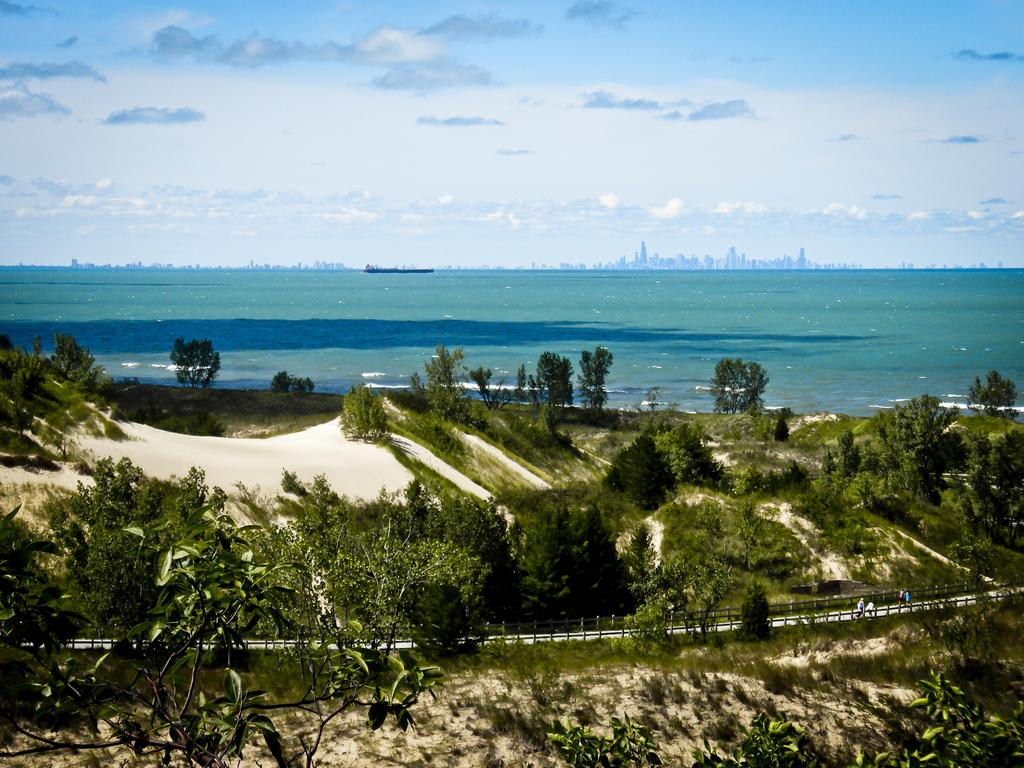What is located in the middle of the image? There are trees in the middle of the image. What can be seen on the right side of the image? There appear to be persons on the right side of the image. What is visible in the background of the image? There is water visible in the background of the image. What is visible at the top of the image? The sky is visible at the top of the image. Reasoning: Let's think step by step by step in order to produce the conversation. We start by identifying the main subjects and objects in the image based on the provided facts. We then formulate questions that focus on the location and characteristics of these subjects and objects, ensuring that each question can be answered definitively with the information given. We avoid yes/no questions and ensure that the language is simple and clear. Absurd Question/Answer: Can you tell me how many tins are being held by the persons on the right side of the image? There is no mention of tins or any objects being held by the persons in the image. What type of wristwatch is visible on the person's wrist in the image? There is no wristwatch or any object on a person's wrist visible in the image. What type of harbor can be seen in the image? There is no harbor present in the image. What type of tin is being used by the persons on the right side of the image? There is no tin or any object being used by the persons in the image. 